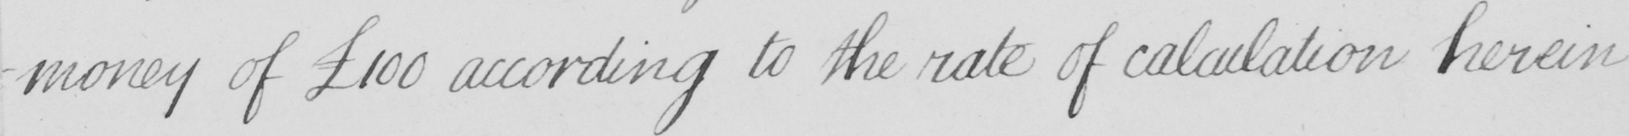Please provide the text content of this handwritten line. -money of  £100 according to the rate of calculation herein 